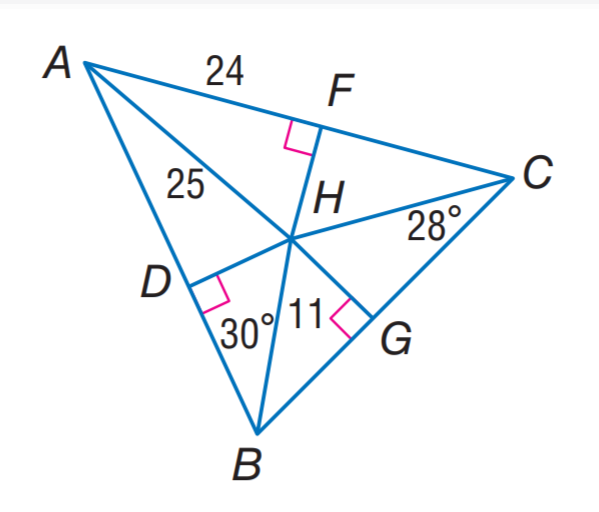Question: H is the incenter of \triangle A B C. Find m \angle H A C.
Choices:
A. 25
B. 28
C. 30
D. 32
Answer with the letter. Answer: D Question: H is the incenter of \triangle A B C. Find B D.
Choices:
A. \frac { 7 } { \sqrt 3 }
B. 7
C. 7 \sqrt 3
D. 14
Answer with the letter. Answer: C Question: H is the incenter of \triangle A B C. Find D H.
Choices:
A. 7
B. 11
C. 24
D. 25
Answer with the letter. Answer: A Question: H is the incenter of \triangle A B C. Find m \angle D H G.
Choices:
A. 60
B. 100
C. 120
D. 150
Answer with the letter. Answer: C 